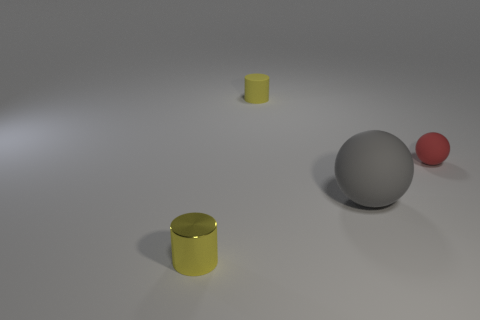The yellow matte thing that is the same size as the yellow shiny cylinder is what shape? The yellow matte object, which is of identical size to the shiny yellow cylinder, is also a cylinder. It’s matte finish gives it a non-reflective surface compared to its glossy counterpart. 